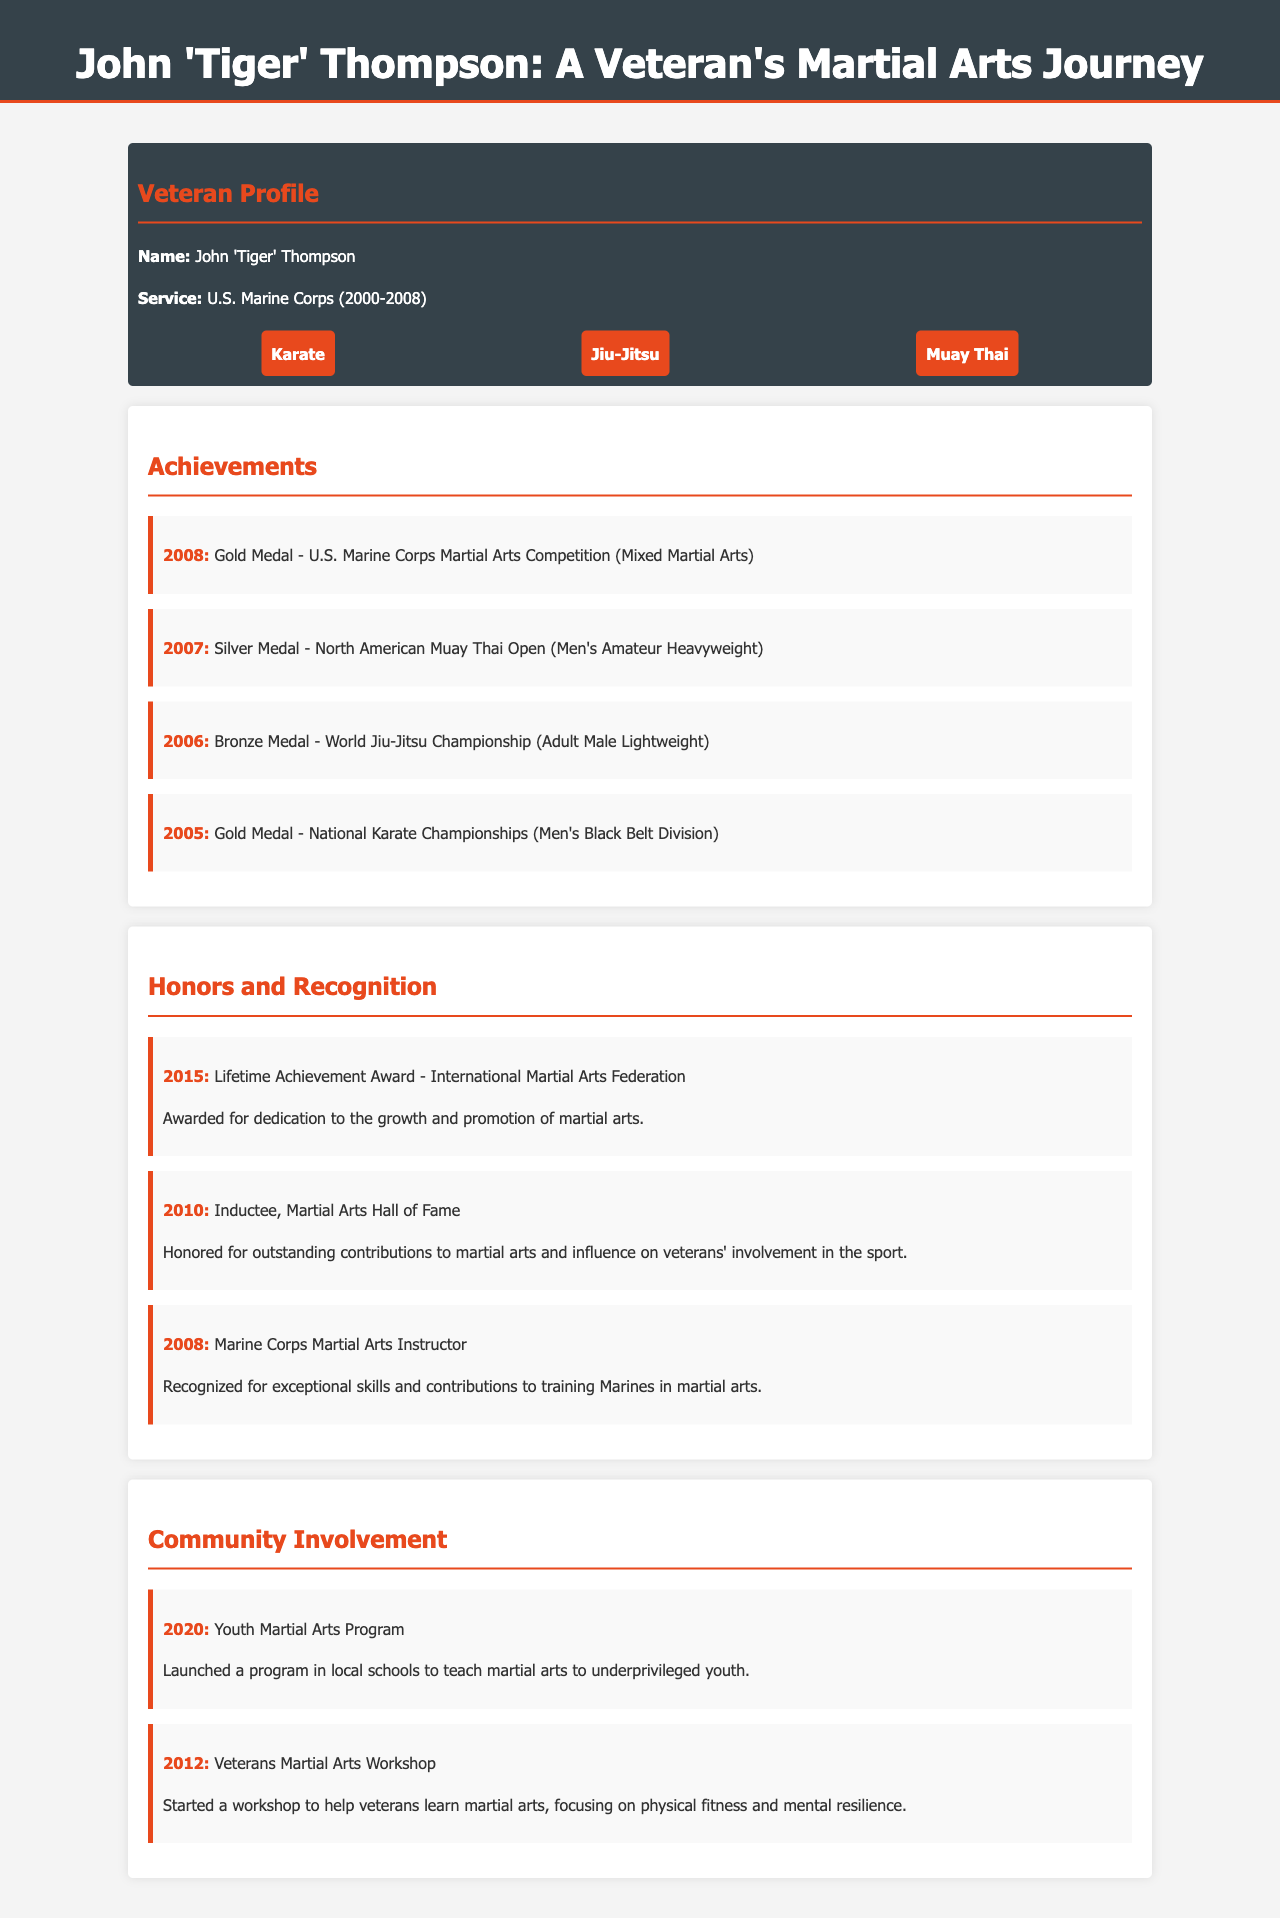What is John 'Tiger' Thompson's military service period? The document states he served in the U.S. Marine Corps from 2000 to 2008.
Answer: 2000-2008 What award did John receive in 2008 at the U.S. Marine Corps Martial Arts Competition? He received a Gold Medal in the competition held in that year.
Answer: Gold Medal In which year did John Thompson receive a Lifetime Achievement Award? This award was given to him in 2015 for his contributions to martial arts.
Answer: 2015 What medal did John achieve in the World Jiu-Jitsu Championship of 2006? The document indicates he won a Bronze Medal in that championship.
Answer: Bronze Medal Which community program did John launch in 2020? He launched a Youth Martial Arts Program aimed at underprivileged youth.
Answer: Youth Martial Arts Program How many disciplines is John trained in as mentioned in the document? The document lists three disciplines in which John is trained.
Answer: Three What is the significance of the award received in 2010? The document mentions he was honored for outstanding contributions to martial arts.
Answer: Outstanding contributions Which competition did John participate in to win a Silver Medal in 2007? He won this medal at the North American Muay Thai Open that year.
Answer: North American Muay Thai Open What was the primary focus of the Veterans Martial Arts Workshop started by John? The workshop aimed to help veterans enhance their physical fitness and mental resilience through martial arts.
Answer: Physical fitness and mental resilience 